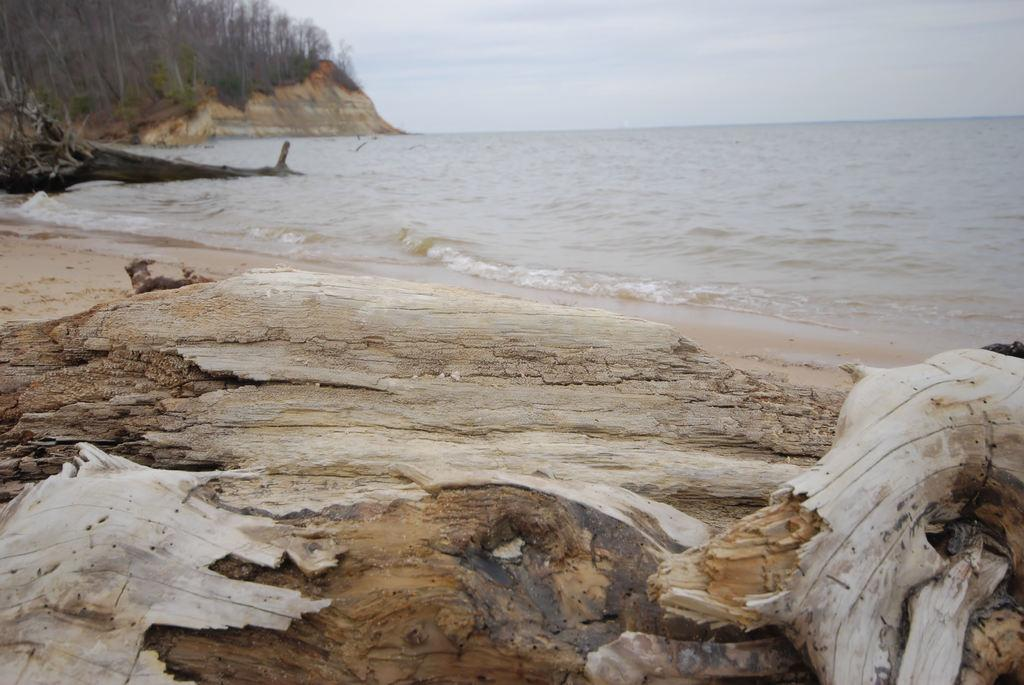What is located at the bottom of the image? There is a wooden stem at the bottom of the image. What is in front of the wooden stem? There is a river in front of the wooden stem. What can be seen in the background of the image? There are trees and the sky visible in the background of the image. What type of turkey can be seen walking in the front of the image? There is no turkey present in the image. Can you tell me the name of the son who is standing near the wooden stem in the image? There is no person, including a son, present in the image. 